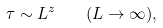Convert formula to latex. <formula><loc_0><loc_0><loc_500><loc_500>\tau \sim L ^ { z } \quad ( L \rightarrow \infty ) ,</formula> 